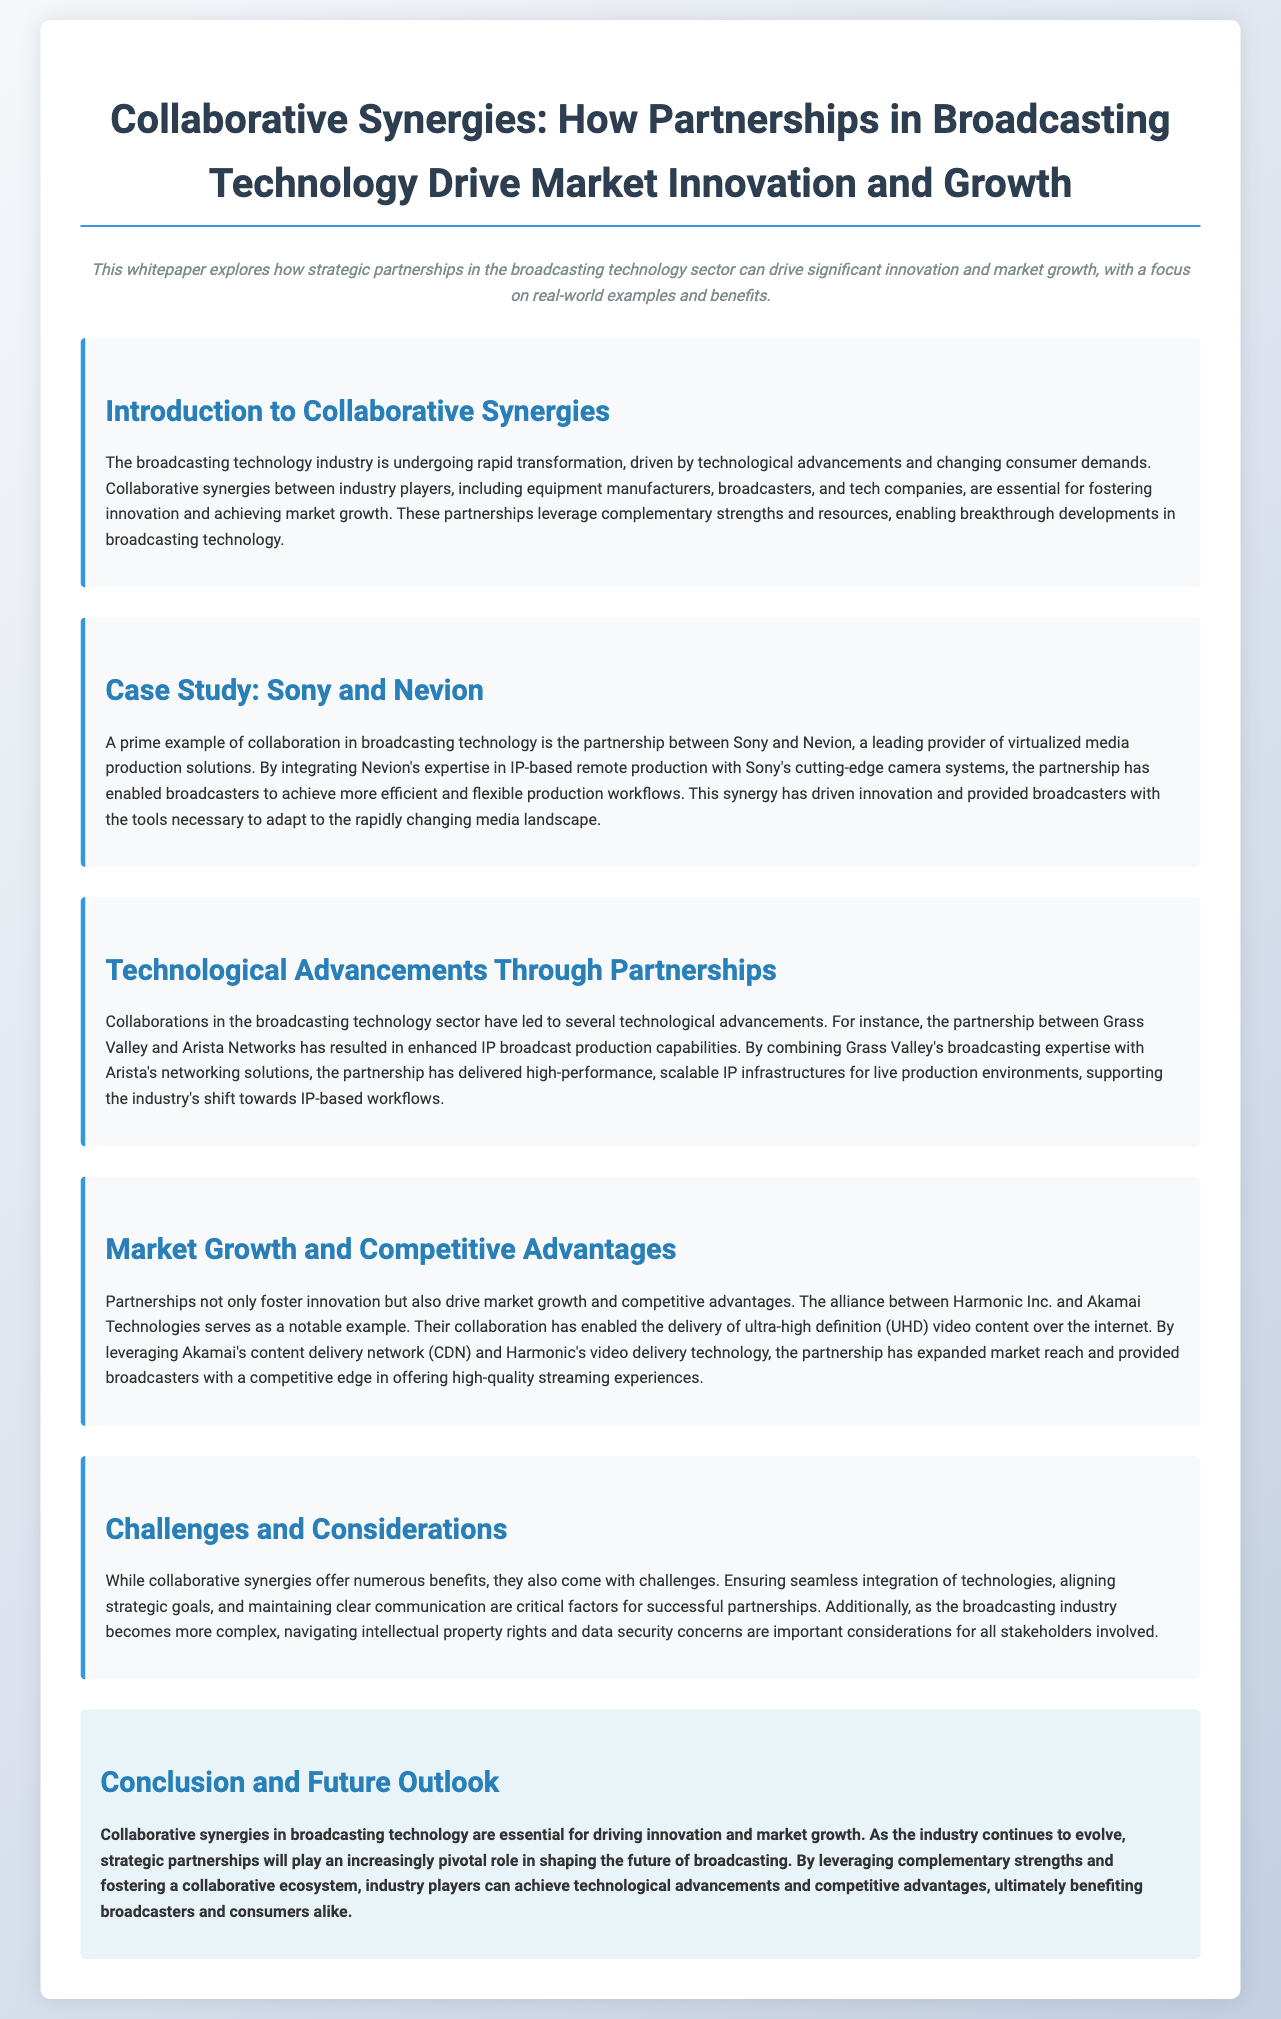What is the title of the whitepaper? The title is explicitly stated at the beginning of the document.
Answer: Collaborative Synergies: How Partnerships in Broadcasting Technology Drive Market Innovation and Growth Who are the two companies involved in the case study? The case study specifically mentions two companies and their collaboration in the broadcasting sector.
Answer: Sony and Nevion What technology did Harmonic Inc. and Akamai Technologies collaborate on? The document indicates the specific technology enabled through this alliance as highlighted in the market growth section.
Answer: Ultra-high definition (UHD) video content What is one challenge of collaborative synergies mentioned in the document? The document lists challenges associated with partnerships in the broadcasting technology sector.
Answer: Intellectual property rights What is the primary benefit of partnerships in broadcasting technology? The document summarizes the key advantages of partnerships within the industry.
Answer: Driving innovation and market growth What is the focus of the introduction section? The introduction elaborates on the importance of partnerships in transforming the broadcasting technology industry.
Answer: Collaborative synergies between industry players Which company's technology is combined with Arista's networking solutions for enhanced capabilities? The document points out a specific company that collaborates with Arista for improved broadcasting technology.
Answer: Grass Valley What is a notion emphasized for future collaborative efforts in broadcasting? The conclusion suggests a notion that will be vital as the broadcasting industry evolves.
Answer: Strategic partnerships 